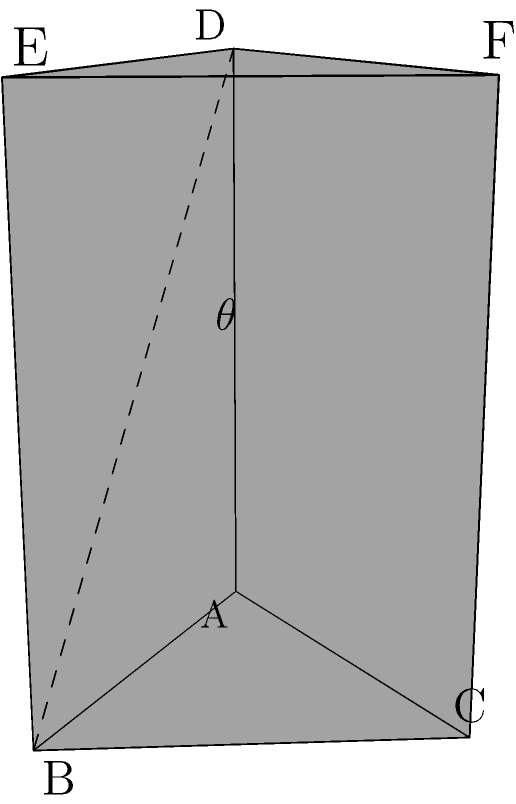A triangular prism represents a protest sign used by a marginalized community to advocate for equality. The angle between the front face (ABC) and the side face (ABDE) of the prism symbolizes the tension between the community and the discriminatory practices. If the height of the prism is 3 units, the base is an equilateral triangle with side length 2 units, what is the angle $\theta$ (in degrees) between these two planes? To find the angle between the two planes, we need to follow these steps:

1) First, we need to find the normal vectors of both planes:
   - For plane ABC: $\vec{n_1} = (0, 0, 1)$
   - For plane ABDE, we need to find two vectors on this plane and take their cross product:
     $\vec{v} = (2, 0, 0)$ and $\vec{w} = (0, 0, 3)$
     $\vec{n_2} = \vec{v} \times \vec{w} = (0, 6, 0)$

2) The angle between the planes is the complement of the angle between their normal vectors. We can find this using the dot product formula:

   $\cos \theta = \frac{\vec{n_1} \cdot \vec{n_2}}{|\vec{n_1}||\vec{n_2}|}$

3) Substituting the values:
   $\cos \theta = \frac{(0, 0, 1) \cdot (0, 6, 0)}{\sqrt{1^2}\sqrt{6^2}} = \frac{0}{6} = 0$

4) Therefore, $\theta = \arccos(0) = 90°$

The angle between the two planes is 90°, representing the stark contrast between the community's values and the discriminatory practices they're protesting against.
Answer: 90° 